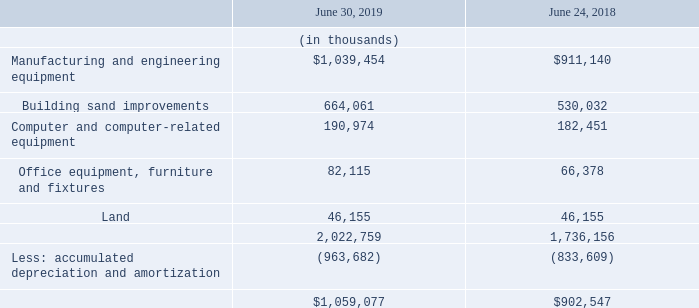Note 11: Property and Equipment
Property and equipment, net, consist of the following:
Depreciation expense, including amortization of capital leases, during fiscal years 2019, 2018, and 2017, was $182.1 million, $165.2 million, and $152.3 million, respectively.
What is the depreciation expense, including amortization of capital leases, during fiscal year 2019? $182.1 million. What is the Manufacturing and engineering equipment amount as of June 30, 2019?
Answer scale should be: thousand. $1,039,454. What is the buildings and improvements amount as of June 30, 2019?
Answer scale should be: thousand. 664,061. What is the percentage change in the Depreciation expense, including amortization of capital leases, from 2018 to 2019?
Answer scale should be: percent. (182.1-165.2)/165.2
Answer: 10.23. What is the percentage change in the accumulated depreciation and amortization from 2018 to 2019?
Answer scale should be: percent. (963,682-833,609)/833,609
Answer: 15.6. In which year is the net amount of property and equipment higher? Find the year with the higher net property and equipment
Answer: 2019. 